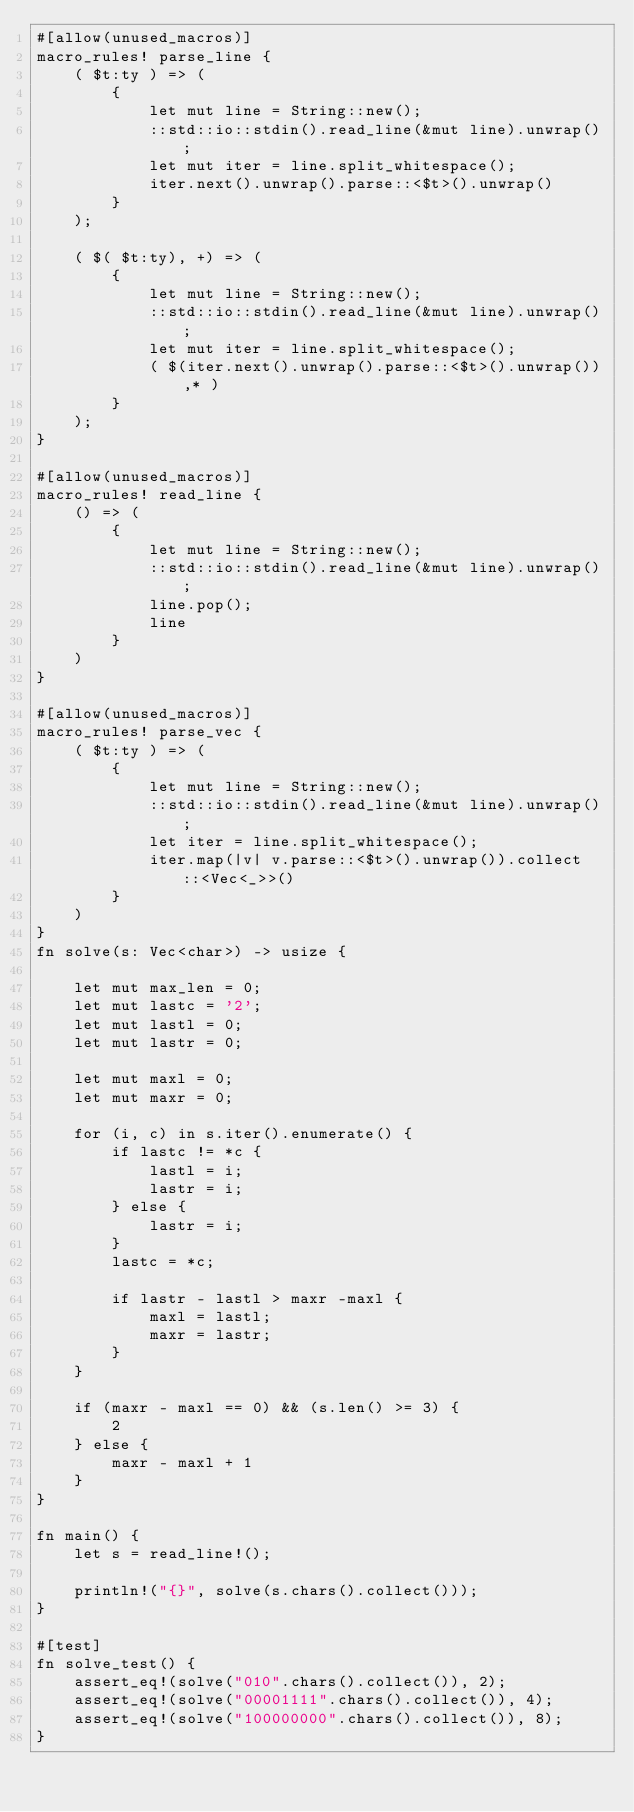<code> <loc_0><loc_0><loc_500><loc_500><_Rust_>#[allow(unused_macros)]
macro_rules! parse_line {
    ( $t:ty ) => (
        {
            let mut line = String::new();
            ::std::io::stdin().read_line(&mut line).unwrap();
            let mut iter = line.split_whitespace();
            iter.next().unwrap().parse::<$t>().unwrap()
        }
    );

    ( $( $t:ty), +) => (
        {
            let mut line = String::new();
            ::std::io::stdin().read_line(&mut line).unwrap();
            let mut iter = line.split_whitespace();
            ( $(iter.next().unwrap().parse::<$t>().unwrap()),* )
        }
    );
}

#[allow(unused_macros)]
macro_rules! read_line {
    () => (
        {
            let mut line = String::new();
            ::std::io::stdin().read_line(&mut line).unwrap();
            line.pop();
            line
        }
    )
}

#[allow(unused_macros)]
macro_rules! parse_vec {
    ( $t:ty ) => (
        {
            let mut line = String::new();
            ::std::io::stdin().read_line(&mut line).unwrap();
            let iter = line.split_whitespace();
            iter.map(|v| v.parse::<$t>().unwrap()).collect::<Vec<_>>()
        }
    )
}
fn solve(s: Vec<char>) -> usize {

    let mut max_len = 0;
    let mut lastc = '2';
    let mut lastl = 0;
    let mut lastr = 0;

    let mut maxl = 0;
    let mut maxr = 0;

    for (i, c) in s.iter().enumerate() {
        if lastc != *c {
            lastl = i;
            lastr = i;
        } else {
            lastr = i;
        }
        lastc = *c;

        if lastr - lastl > maxr -maxl {
            maxl = lastl;
            maxr = lastr;
        }
    }

    if (maxr - maxl == 0) && (s.len() >= 3) {
        2
    } else {
        maxr - maxl + 1
    }
}

fn main() {
    let s = read_line!();

    println!("{}", solve(s.chars().collect()));
}

#[test]
fn solve_test() {
    assert_eq!(solve("010".chars().collect()), 2);
    assert_eq!(solve("00001111".chars().collect()), 4);
    assert_eq!(solve("100000000".chars().collect()), 8);
}
</code> 